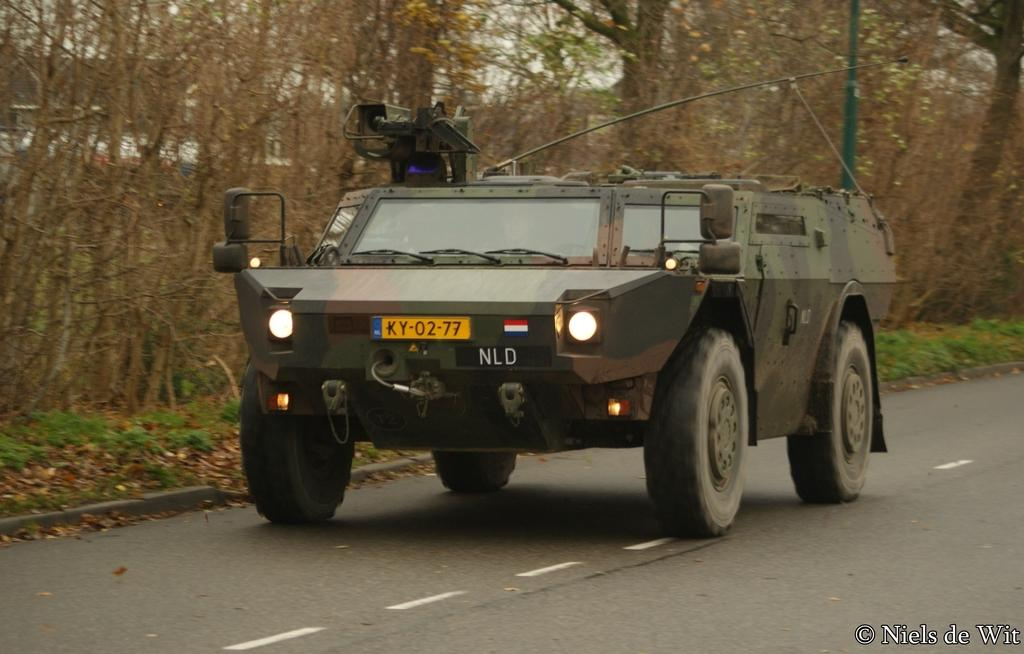What is the main subject of the image? There is a vehicle on the road in the image. What can be seen in the background of the image? Plants, grass, and trees are visible in the background of the image. Is there any text present in the image? Yes, there is some text in the right side bottom corner of the image. How many toes can be seen on the vehicle in the image? Vehicles do not have toes, so none can be seen on the vehicle in the image. Can you provide an example of a similar image with a different vehicle? The provided facts do not include any other images, so it is not possible to provide an example of a similar image with a different vehicle. 